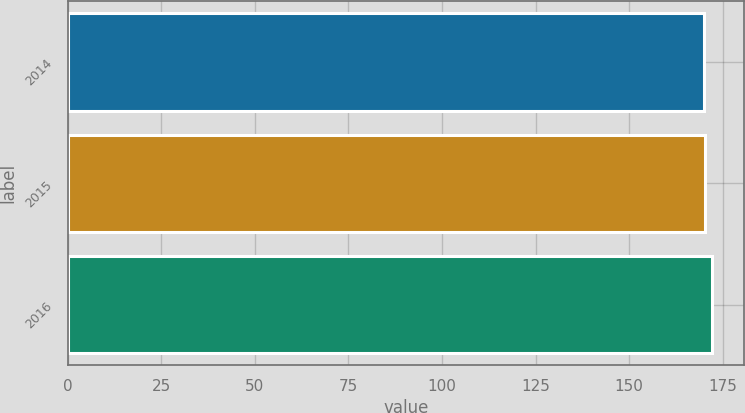<chart> <loc_0><loc_0><loc_500><loc_500><bar_chart><fcel>2014<fcel>2015<fcel>2016<nl><fcel>170<fcel>170.2<fcel>172<nl></chart> 